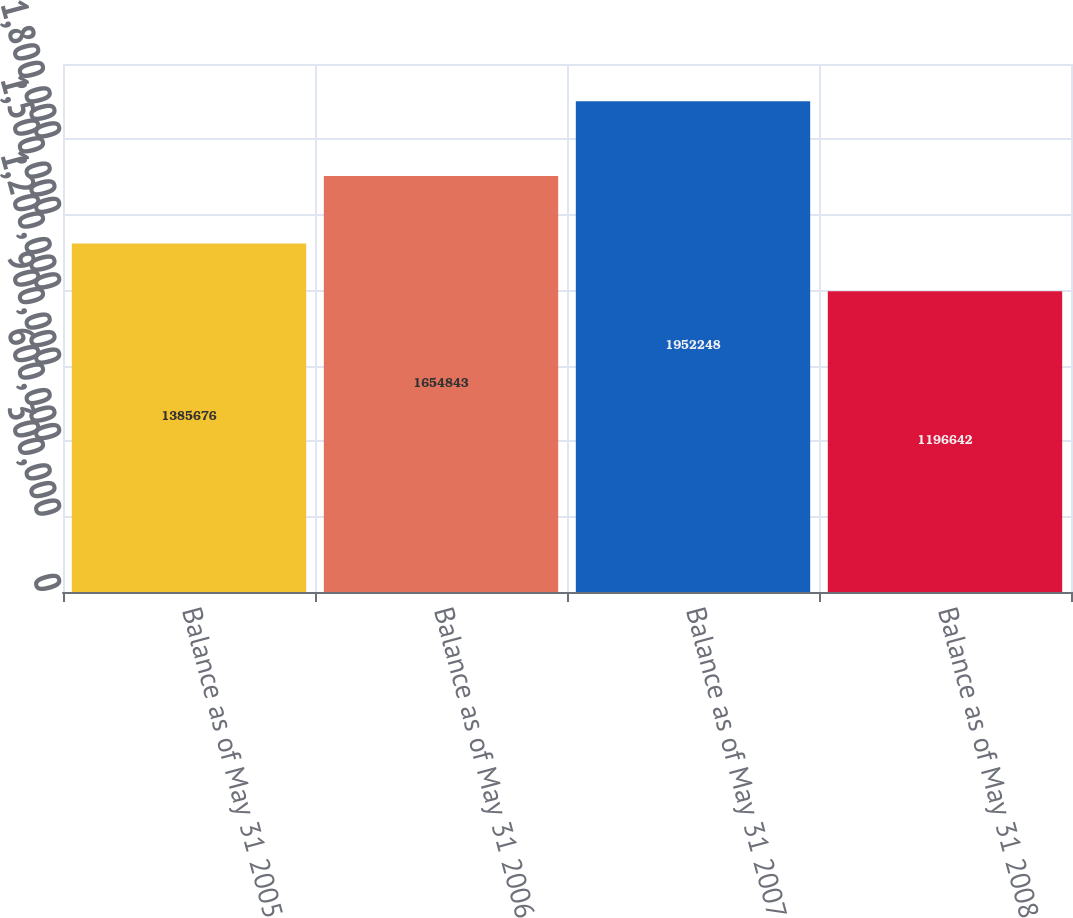Convert chart. <chart><loc_0><loc_0><loc_500><loc_500><bar_chart><fcel>Balance as of May 31 2005<fcel>Balance as of May 31 2006<fcel>Balance as of May 31 2007<fcel>Balance as of May 31 2008<nl><fcel>1.38568e+06<fcel>1.65484e+06<fcel>1.95225e+06<fcel>1.19664e+06<nl></chart> 